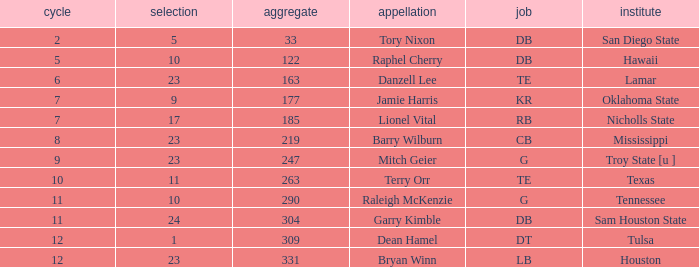Which Round is the highest one that has a Pick smaller than 10, and a Name of tory nixon? 2.0. I'm looking to parse the entire table for insights. Could you assist me with that? {'header': ['cycle', 'selection', 'aggregate', 'appellation', 'job', 'institute'], 'rows': [['2', '5', '33', 'Tory Nixon', 'DB', 'San Diego State'], ['5', '10', '122', 'Raphel Cherry', 'DB', 'Hawaii'], ['6', '23', '163', 'Danzell Lee', 'TE', 'Lamar'], ['7', '9', '177', 'Jamie Harris', 'KR', 'Oklahoma State'], ['7', '17', '185', 'Lionel Vital', 'RB', 'Nicholls State'], ['8', '23', '219', 'Barry Wilburn', 'CB', 'Mississippi'], ['9', '23', '247', 'Mitch Geier', 'G', 'Troy State [u ]'], ['10', '11', '263', 'Terry Orr', 'TE', 'Texas'], ['11', '10', '290', 'Raleigh McKenzie', 'G', 'Tennessee'], ['11', '24', '304', 'Garry Kimble', 'DB', 'Sam Houston State'], ['12', '1', '309', 'Dean Hamel', 'DT', 'Tulsa'], ['12', '23', '331', 'Bryan Winn', 'LB', 'Houston']]} 